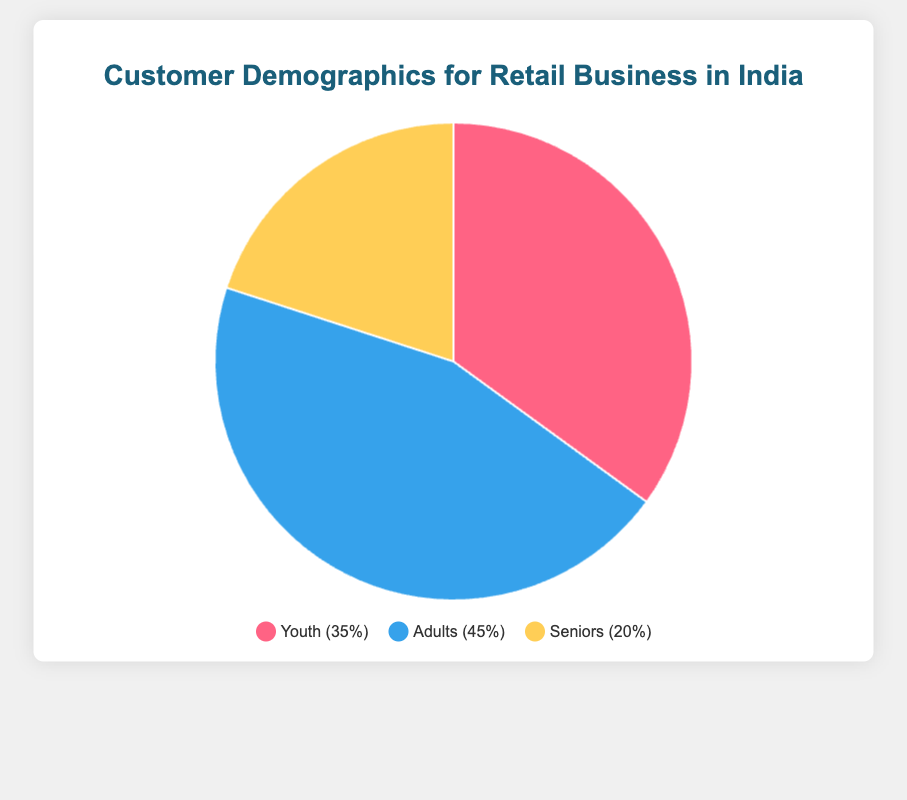Which age group holds the largest portion of the customer base? The pie chart indicates that Adults form the largest section with 45%.
Answer: Adults Which age group has the smallest portion of the customer base? The smallest portion is represented by Seniors, who account for 20% of the customer base.
Answer: Seniors What is the difference in percentage between the Youth and Seniors age groups? The Youth group has 35% and the Seniors have 20%, so the difference is 35% - 20% = 15%.
Answer: 15% What is the combined percentage of Youth and Seniors in the customer base? Combining the percentages of Youth (35%) and Seniors (20%), you get 35% + 20% = 55%.
Answer: 55% Are there more Adults or the combined group of Youth and Seniors? Adults make up 45% of the base, while Youth and Seniors combined make up 55%. Therefore, there are more in the combined group.
Answer: Combined group of Youth and Seniors Which age group segment is represented by the blue section of the pie chart? The blue section represents the Adults, who make up 45% of the customer base.
Answer: Adults If the pie chart sections are different colors, what color represents the Youth group? The pie chart legend shows that the Youth group is represented by the red section.
Answer: Red What percentage constitutes the difference between the largest and smallest age groups? The largest group is Adults at 45%, and the smallest is Seniors at 20%. The difference is 45% - 20% = 25%.
Answer: 25% Among the three age groups, which two have a combined percentage less than 70%? Youth (35%) and Seniors (20%) combined have 35% + 20% = 55%, which is less than 70%.
Answer: Youth and Seniors If you were to merge the Adults and Youth percentages, what would be the new total? Merging Adults (45%) and Youth (35%) results in 45% + 35% = 80%.
Answer: 80% 